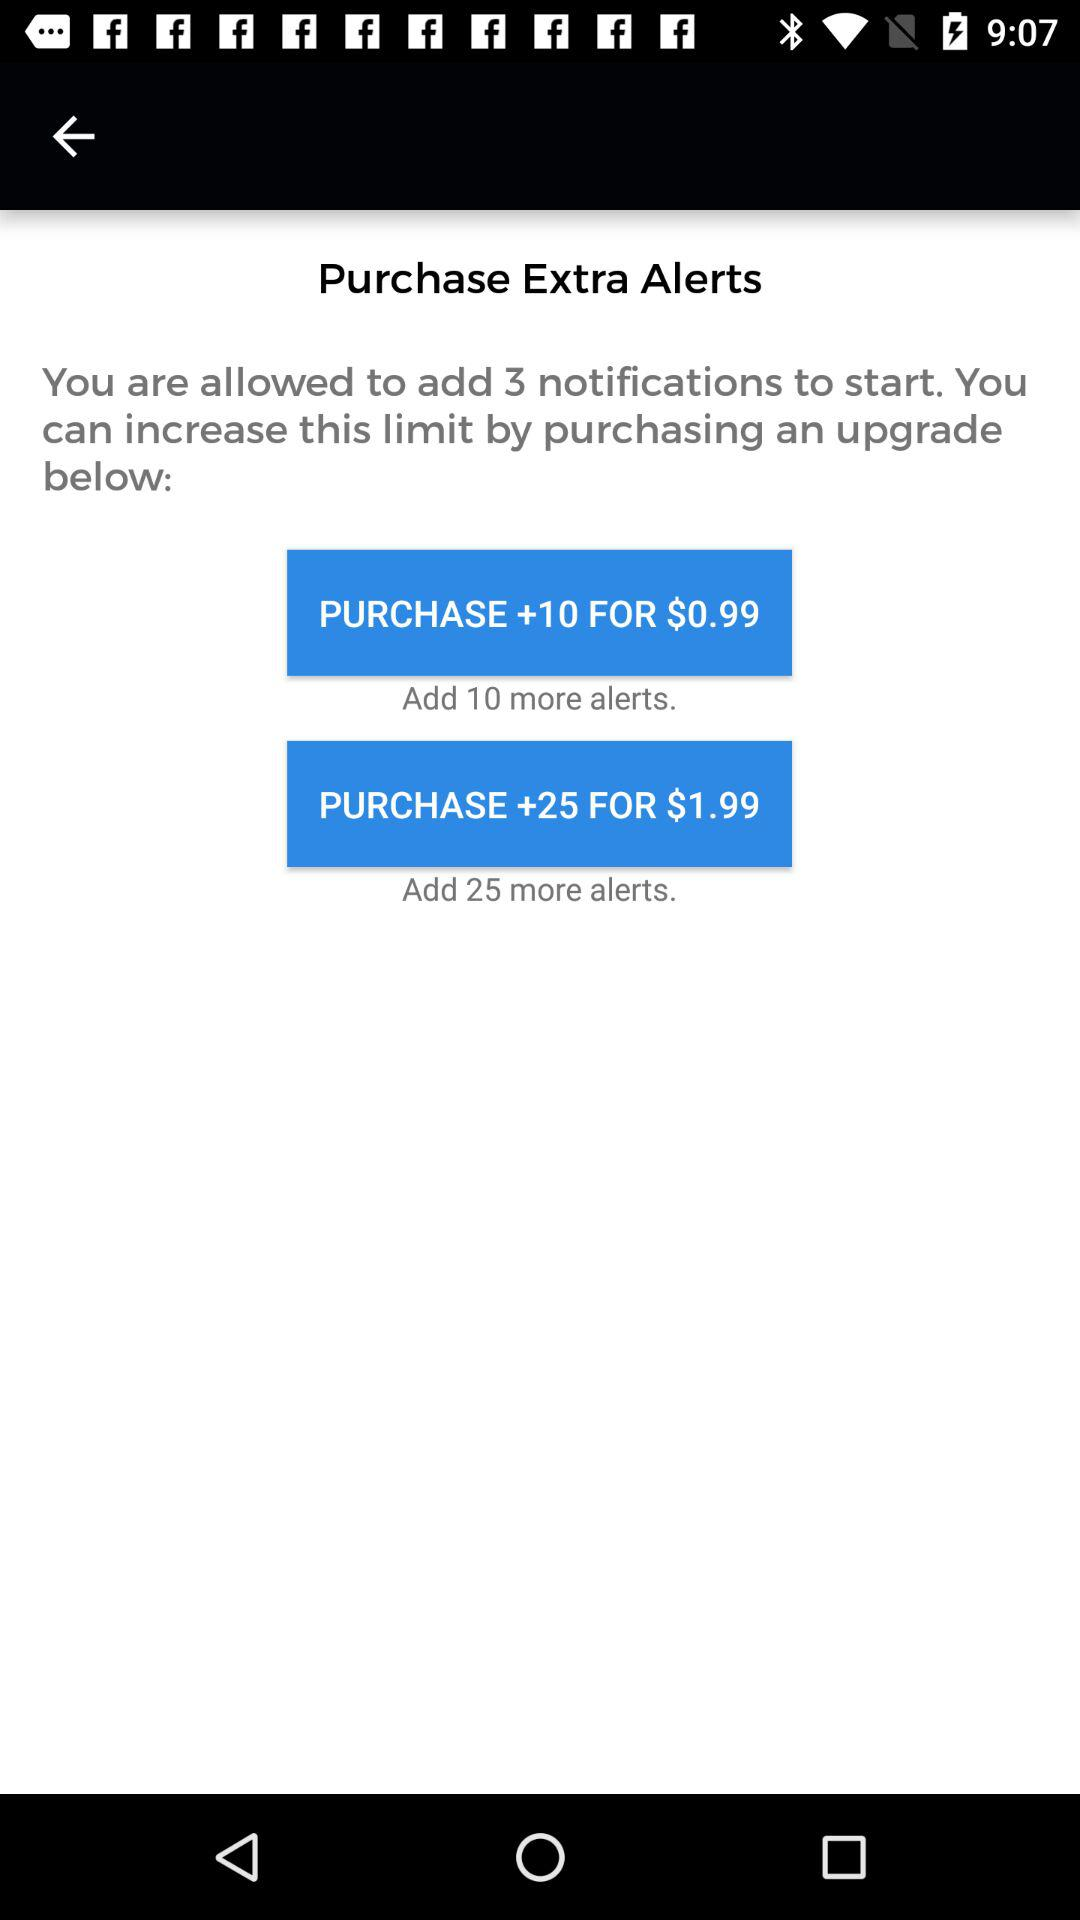How many more alerts can be added for the purchase of $0.99? For the price of $0.99, 10 more alerts can be added. 